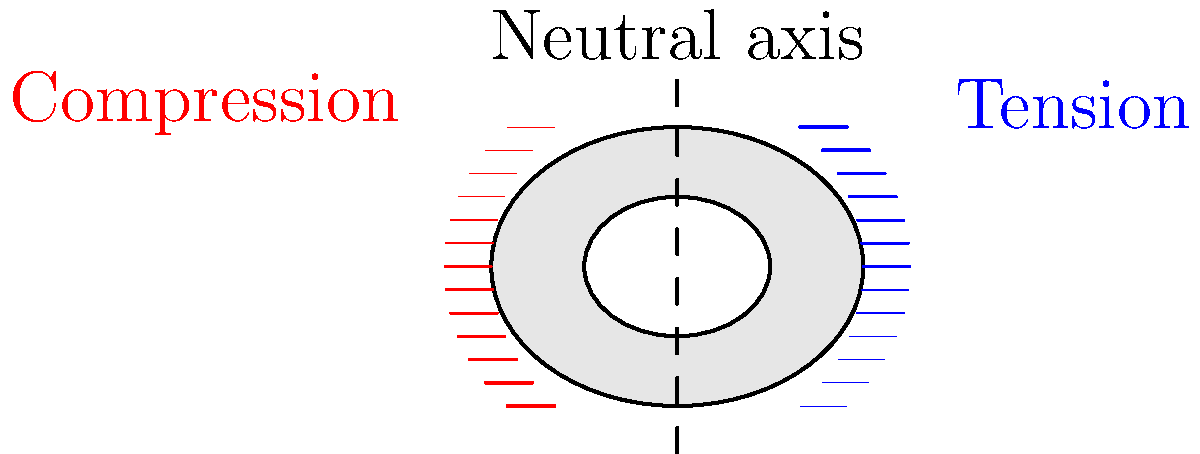In the cross-sectional view of a long bone under bending load, what is the significance of the dashed line running vertically through the center of the bone, and how does it relate to the stress distribution shown by the colored lines? To understand the significance of the dashed line and its relation to the stress distribution, let's follow these steps:

1. Bending load: When a long bone is subjected to a bending load, it experiences both tension and compression forces.

2. Stress distribution: 
   - The blue lines on the right represent tensile stress.
   - The red lines on the left represent compressive stress.
   - The length of these lines indicates the magnitude of stress at each point.

3. Dashed line: The vertical dashed line through the center of the bone represents the neutral axis.

4. Neutral axis:
   - This is the line where the stress changes from tension to compression.
   - At the neutral axis, the stress is zero.

5. Stress variation:
   - Moving away from the neutral axis, the stress increases linearly.
   - Maximum tension occurs at the outermost fibers on the convex side (right).
   - Maximum compression occurs at the outermost fibers on the concave side (left).

6. Relation to stress distribution:
   - The neutral axis divides the cross-section into tension and compression zones.
   - Stress magnitude increases with distance from the neutral axis, as shown by the increasing length of the colored lines.

7. Importance in biomechanics:
   - Understanding this stress distribution helps in analyzing bone strength and fracture risk.
   - It's crucial for designing implants and predicting bone remodeling.

The dashed line (neutral axis) is therefore critical in defining the stress distribution pattern in the bone under bending load.
Answer: The dashed line represents the neutral axis, where stress is zero, dividing tensile and compressive stresses that increase linearly with distance from this axis. 